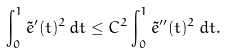<formula> <loc_0><loc_0><loc_500><loc_500>\int _ { 0 } ^ { 1 } \tilde { e } ^ { \prime } ( t ) ^ { 2 } \, d t \leq C ^ { 2 } \int _ { 0 } ^ { 1 } \tilde { e } ^ { \prime \prime } ( t ) ^ { 2 } \, d t .</formula> 